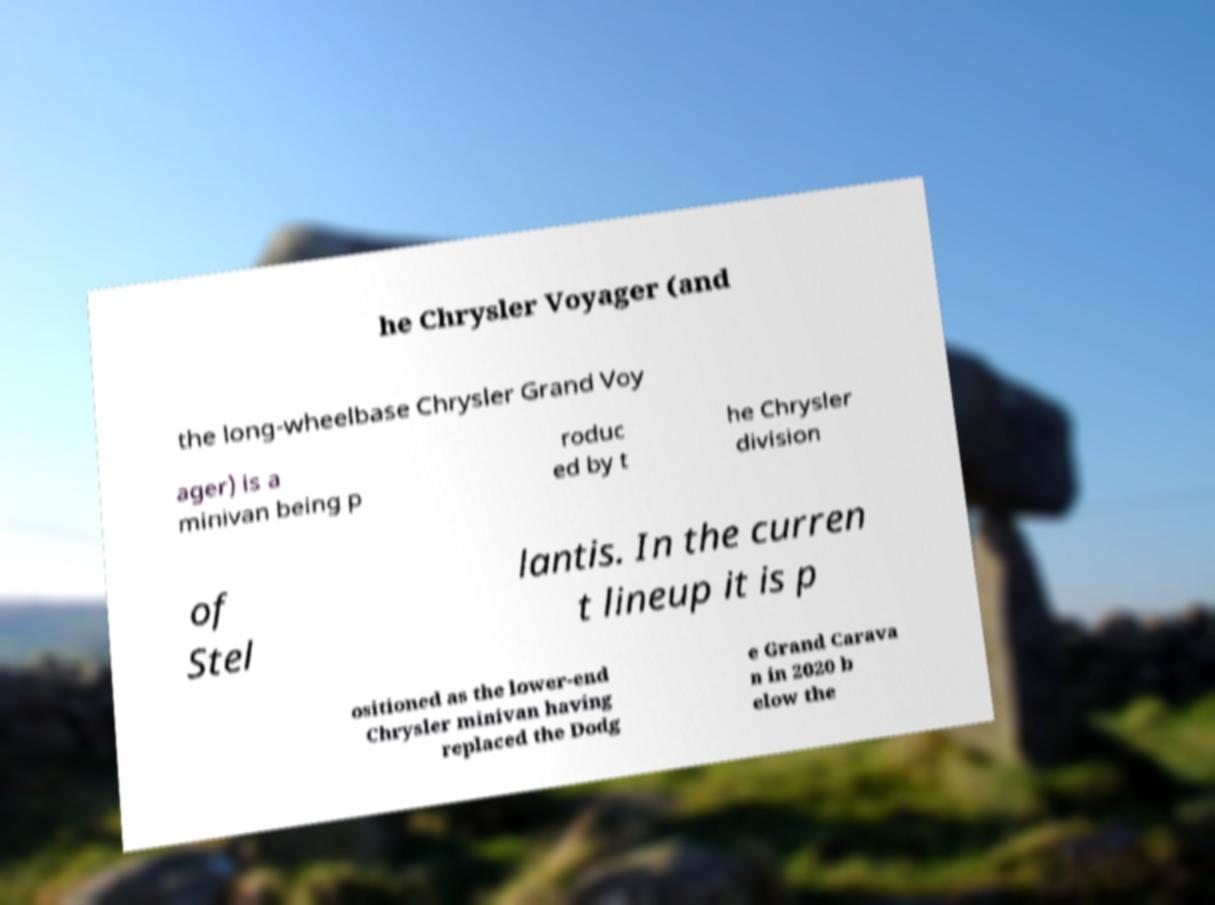Please identify and transcribe the text found in this image. he Chrysler Voyager (and the long-wheelbase Chrysler Grand Voy ager) is a minivan being p roduc ed by t he Chrysler division of Stel lantis. In the curren t lineup it is p ositioned as the lower-end Chrysler minivan having replaced the Dodg e Grand Carava n in 2020 b elow the 